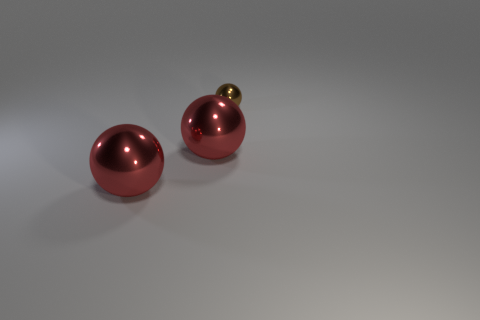Add 1 shiny spheres. How many objects exist? 4 Subtract all large red objects. Subtract all brown balls. How many objects are left? 0 Add 2 brown metallic things. How many brown metallic things are left? 3 Add 1 small yellow blocks. How many small yellow blocks exist? 1 Subtract 0 cyan cubes. How many objects are left? 3 